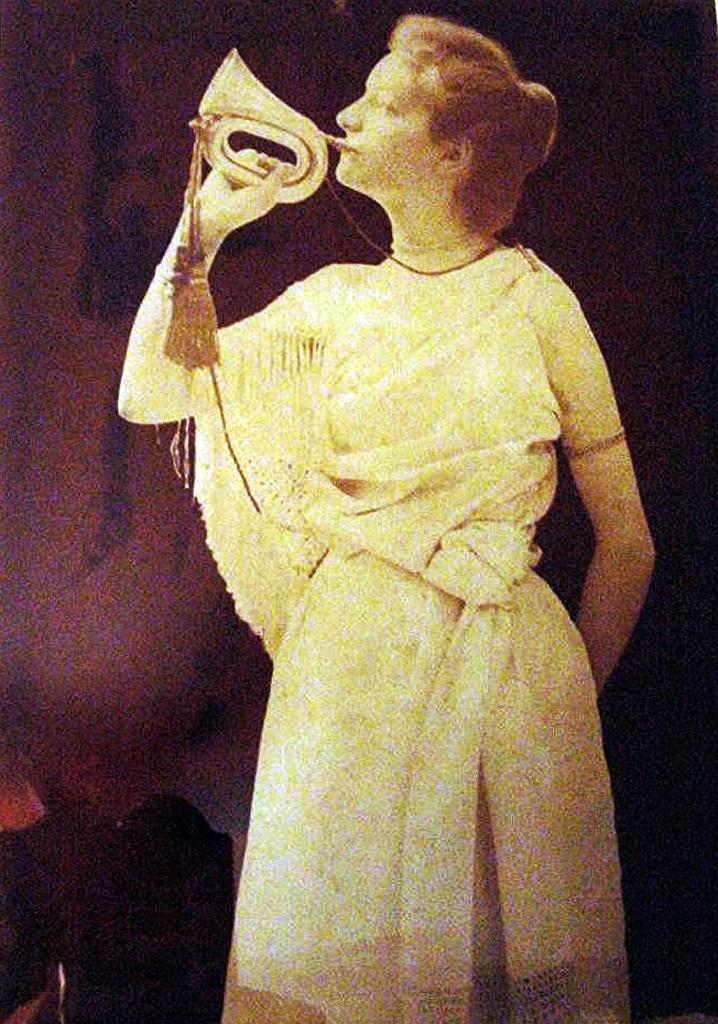Who or what is the main subject in the image? There is a person in the image. What is the person wearing? The person is wearing clothes. What is the person doing in the image? The person is playing a musical instrument. What type of war is the person leading in the image? There is no war or any indication of war in the image; it features a person playing a musical instrument. Who is the governor in the image? There is no mention of a governor or any political figure in the image; it features a person playing a musical instrument. 